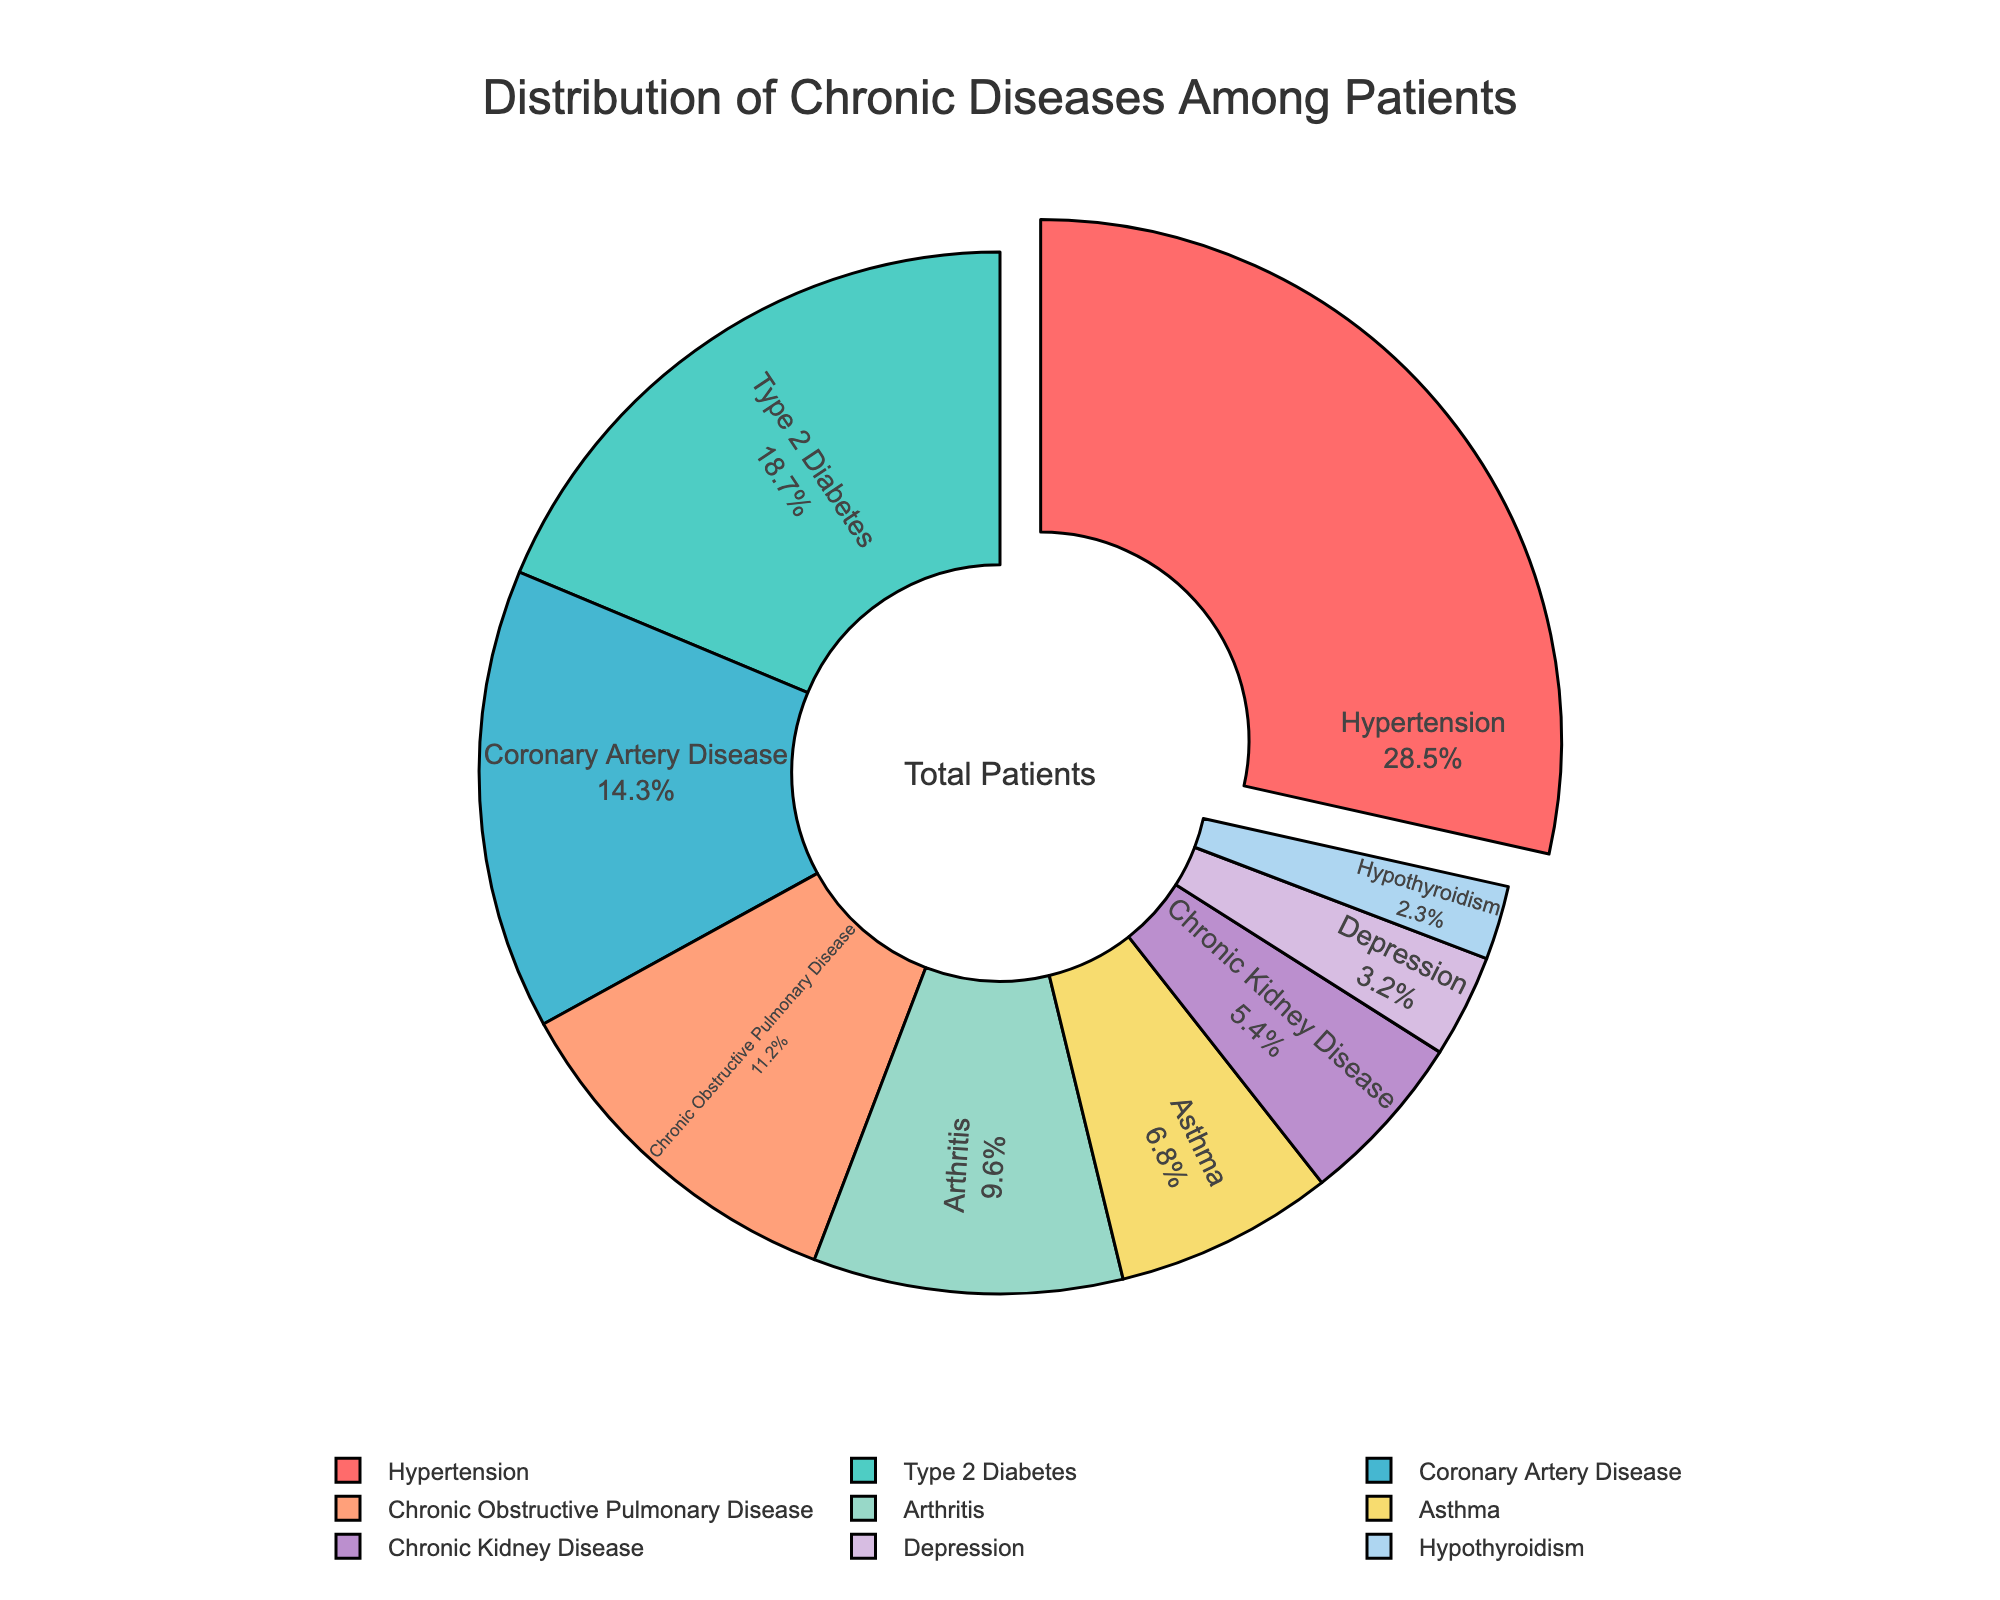Which disease has the highest percentage among patients? To determine the disease with the highest percentage, observe the largest section of the pie chart. Hypertension occupies the largest portion.
Answer: Hypertension Which disease has the lowest percentage among patients? To determine the disease with the lowest percentage, look for the smallest section of the pie chart. Hypothyroidism is the smallest section.
Answer: Hypothyroidism How much higher is the percentage of Hypertension compared to Arthritis? To find the difference, subtract the percentage of Arthritis from the percentage of Hypertension: 28.5 - 9.6 = 18.9
Answer: 18.9 What is the combined percentage of Asthma and Depression? Add the percentages of Asthma and Depression: 6.8 + 3.2 = 10.0
Answer: 10.0 Which disease categories, when combined, make up more than 50% of the distribution? Check combinations of disease percentages until they sum to more than 50%. Hypertension (28.5) + Type 2 Diabetes (18.7) + Coronary Artery Disease (14.3) = 61.5, which is more than 50%.
Answer: Hypertension, Type 2 Diabetes, Coronary Artery Disease How does the percentage of Chronic Obstructive Pulmonary Disease compare to Type 2 Diabetes? Compare the percentages directly: 11.2% (COPD) is less than 18.7% (Type 2 Diabetes).
Answer: Less What is the average percentage of Depression and Hypothyroidism? Add the percentages of Depression and Hypothyroidism, then divide by 2: (3.2 + 2.3) / 2 = 2.75
Answer: 2.75 Which conditions together constitute less than 15% of the patient distribution? Add the percentages of the smallest categories until just under 15%. Depression (3.2) + Hypothyroidism (2.3) = 5.5, then add Chronic Kidney Disease (5.4) and get 10.9%. Adding Asthma (6.8) would exceed 15%.
Answer: Depression, Hypothyroidism, Chronic Kidney Disease Which visually distinct color represents the section with the highest percentage? Observe the color associated with the largest pie section (Hypertension). The chart indicates Hypertension in red.
Answer: Red 